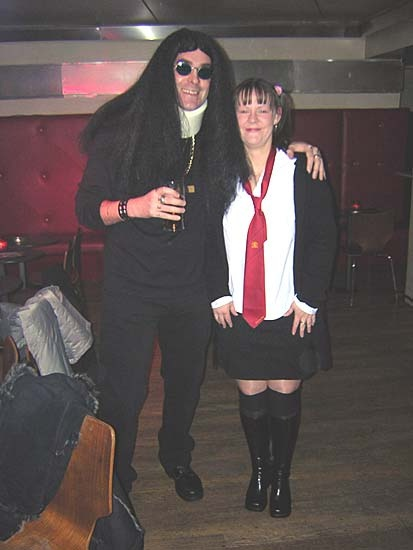Describe the objects in this image and their specific colors. I can see people in gray and black tones, people in gray, black, and white tones, chair in gray and brown tones, chair in gray and black tones, and tie in gray, brown, and white tones in this image. 